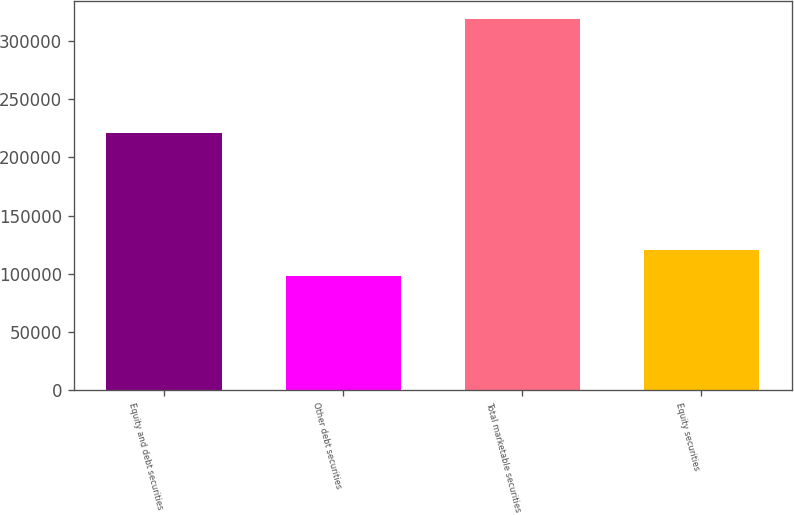Convert chart to OTSL. <chart><loc_0><loc_0><loc_500><loc_500><bar_chart><fcel>Equity and debt securities<fcel>Other debt securities<fcel>Total marketable securities<fcel>Equity securities<nl><fcel>220560<fcel>98010<fcel>318570<fcel>120066<nl></chart> 